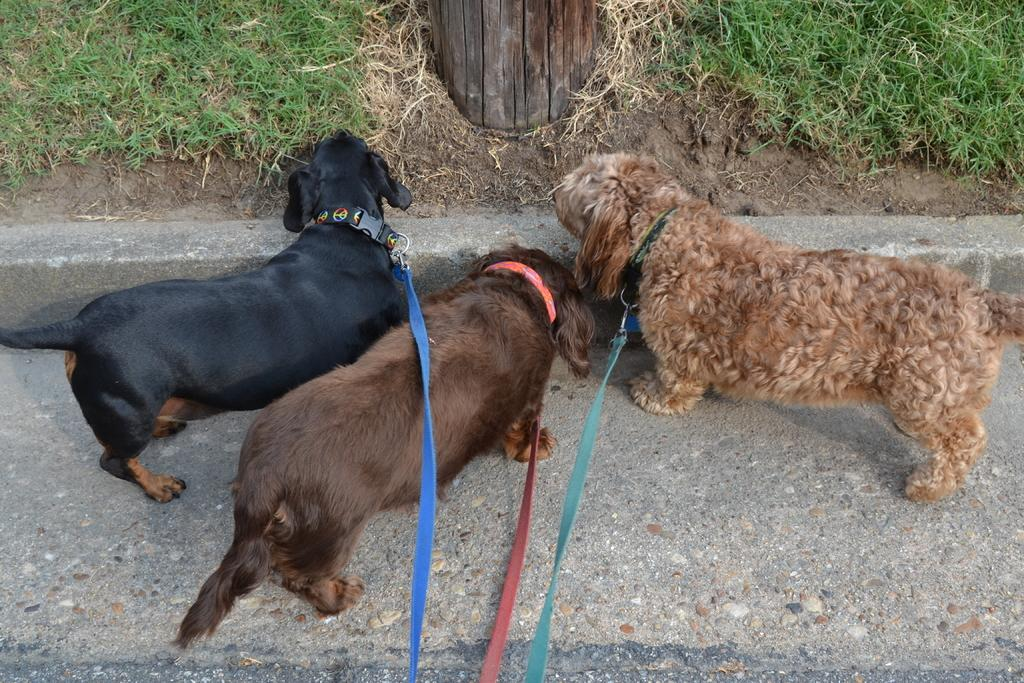How many dogs are in the image? There are three dogs in the image. What are the dogs wearing? The dogs are wearing dog belts. Where are the dogs standing? The dogs are standing on the road. What can be seen in the background of the image? There is grass visible in the background of the image. What year is depicted in the image? The image does not depict a specific year; it is a photograph of three dogs wearing dog belts and standing on the road. 